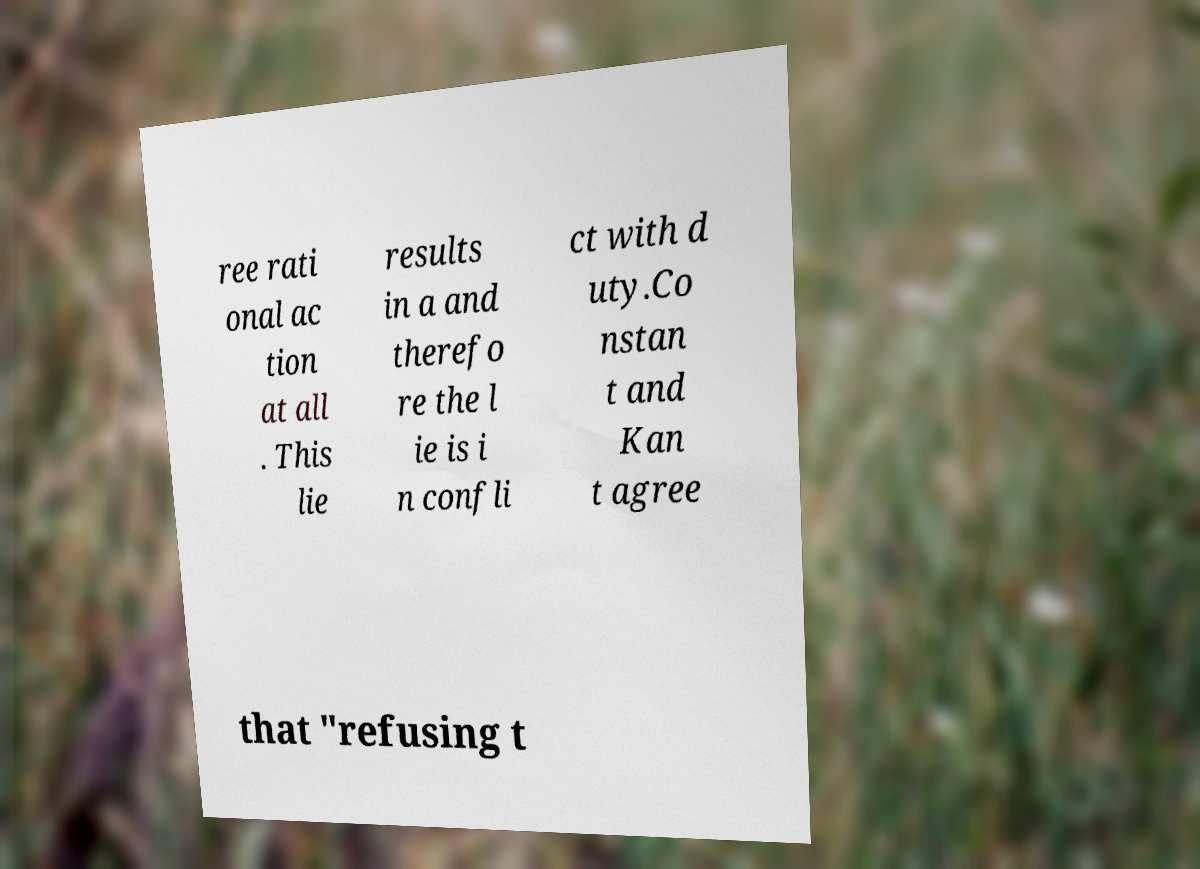Please read and relay the text visible in this image. What does it say? ree rati onal ac tion at all . This lie results in a and therefo re the l ie is i n confli ct with d uty.Co nstan t and Kan t agree that "refusing t 